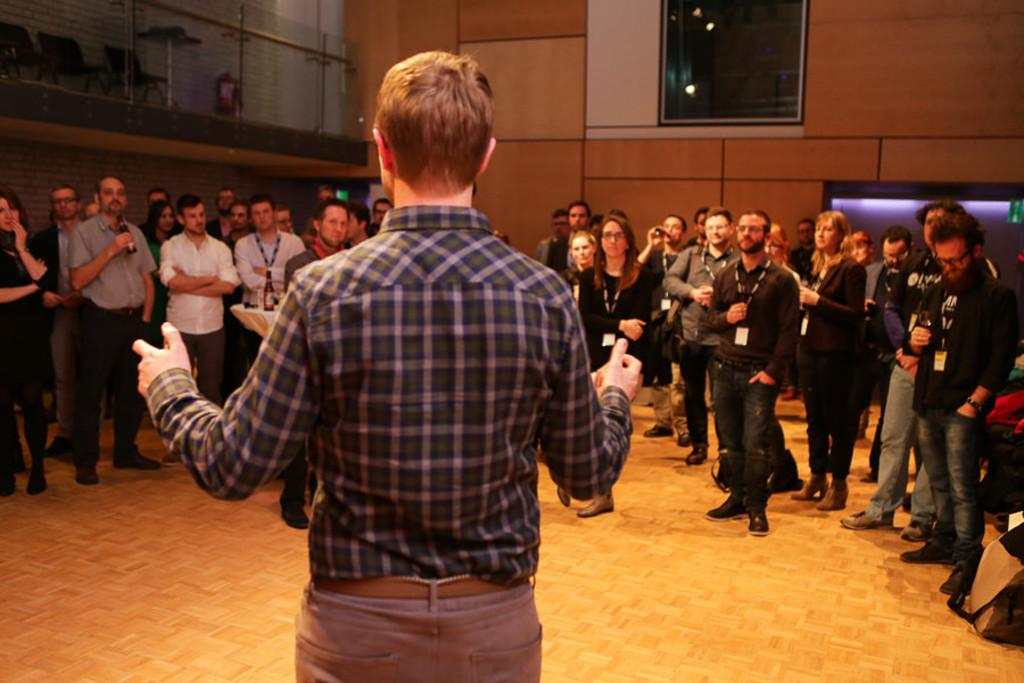How many people are in the group in the image? There is a group of people in the image, but the exact number is not specified. What are the people in the group doing? The people in the group are standing. What can be seen on some of the people in the group? Some people in the group are wearing tags. What can be seen in the background of the image? In the background of the image, there are chairs, a glass object, metal rods, and lights. What type of spoon is being used to stir the glass object in the middle of the image? There is no spoon or stirring activity present in the image. 